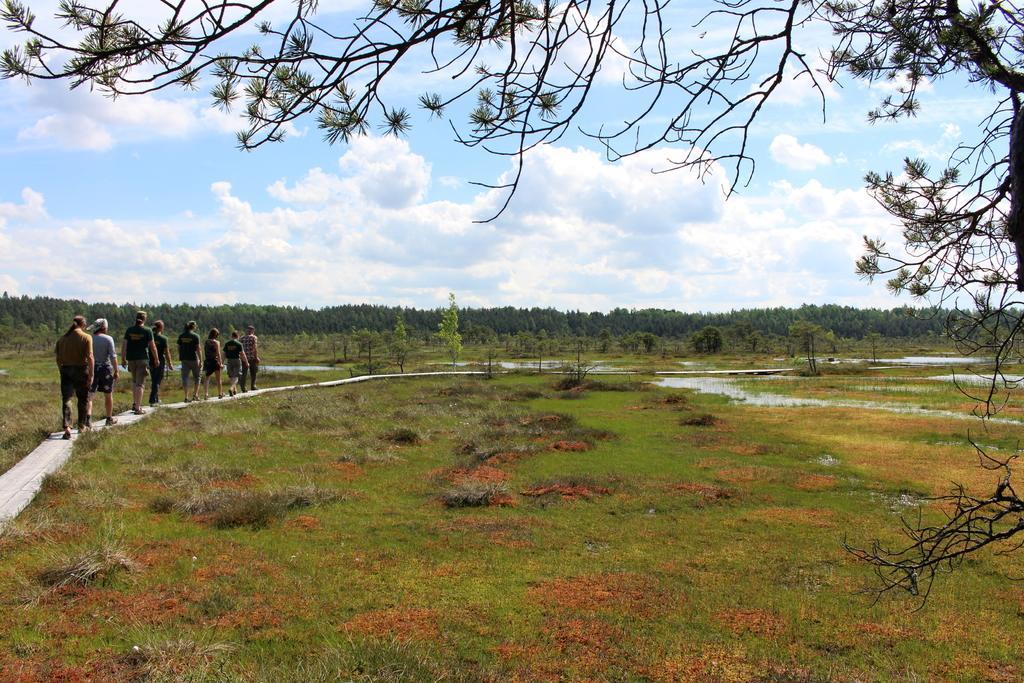Describe this image in one or two sentences. In this image we can see some group of persons who are walking through the walkway and in the background of the image there are some trees and sunny sky, we can see another tree in the foreground of the image. 